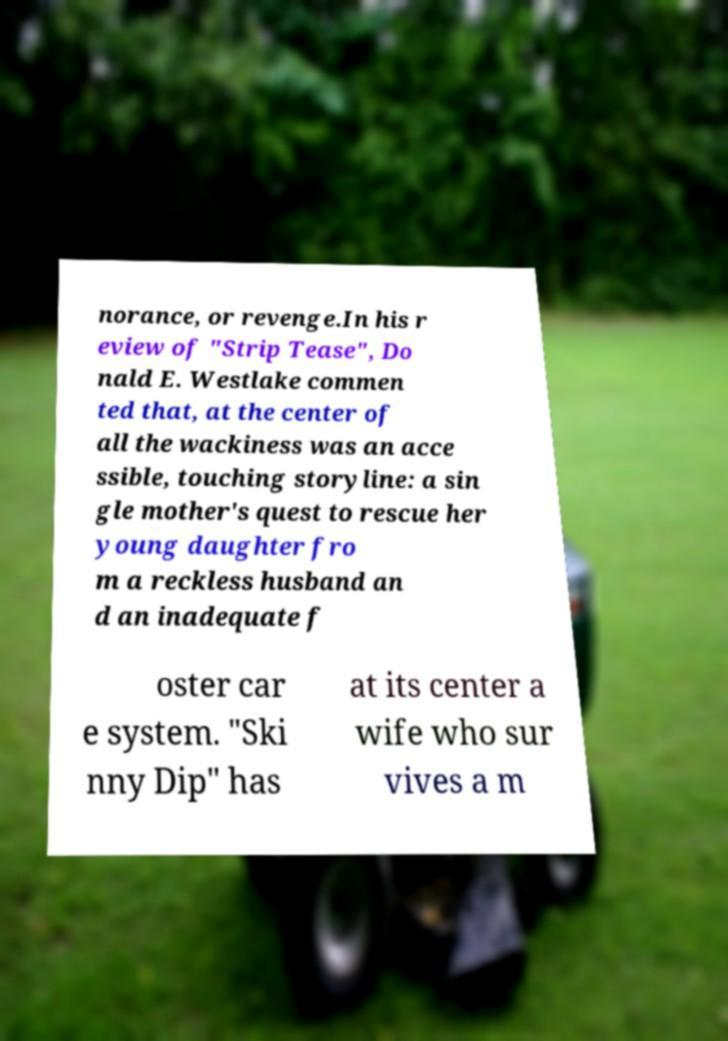I need the written content from this picture converted into text. Can you do that? norance, or revenge.In his r eview of "Strip Tease", Do nald E. Westlake commen ted that, at the center of all the wackiness was an acce ssible, touching storyline: a sin gle mother's quest to rescue her young daughter fro m a reckless husband an d an inadequate f oster car e system. "Ski nny Dip" has at its center a wife who sur vives a m 